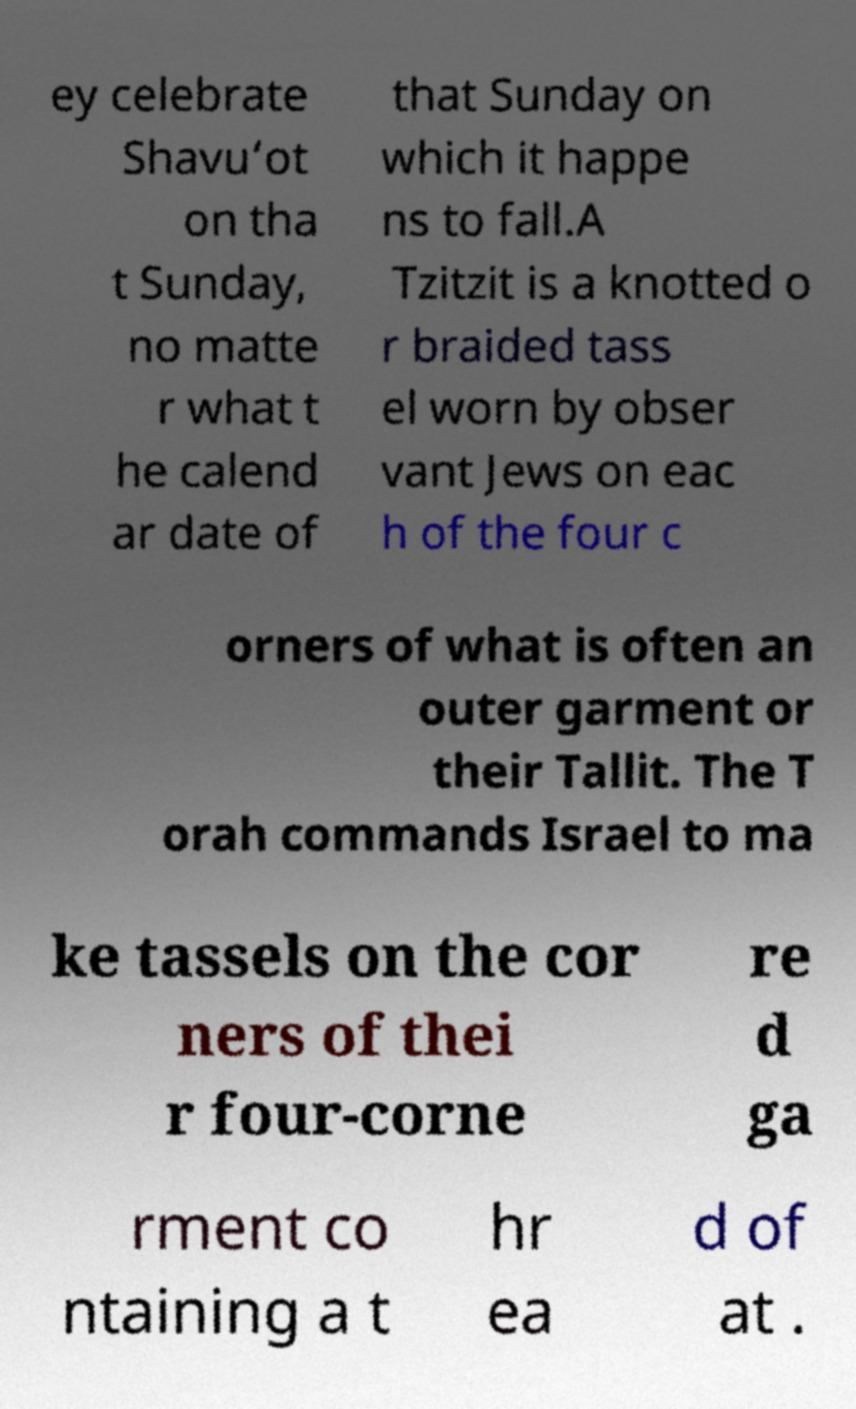I need the written content from this picture converted into text. Can you do that? ey celebrate Shavu‘ot on tha t Sunday, no matte r what t he calend ar date of that Sunday on which it happe ns to fall.A Tzitzit is a knotted o r braided tass el worn by obser vant Jews on eac h of the four c orners of what is often an outer garment or their Tallit. The T orah commands Israel to ma ke tassels on the cor ners of thei r four-corne re d ga rment co ntaining a t hr ea d of at . 